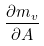Convert formula to latex. <formula><loc_0><loc_0><loc_500><loc_500>\frac { \partial m _ { v } } { \partial A }</formula> 